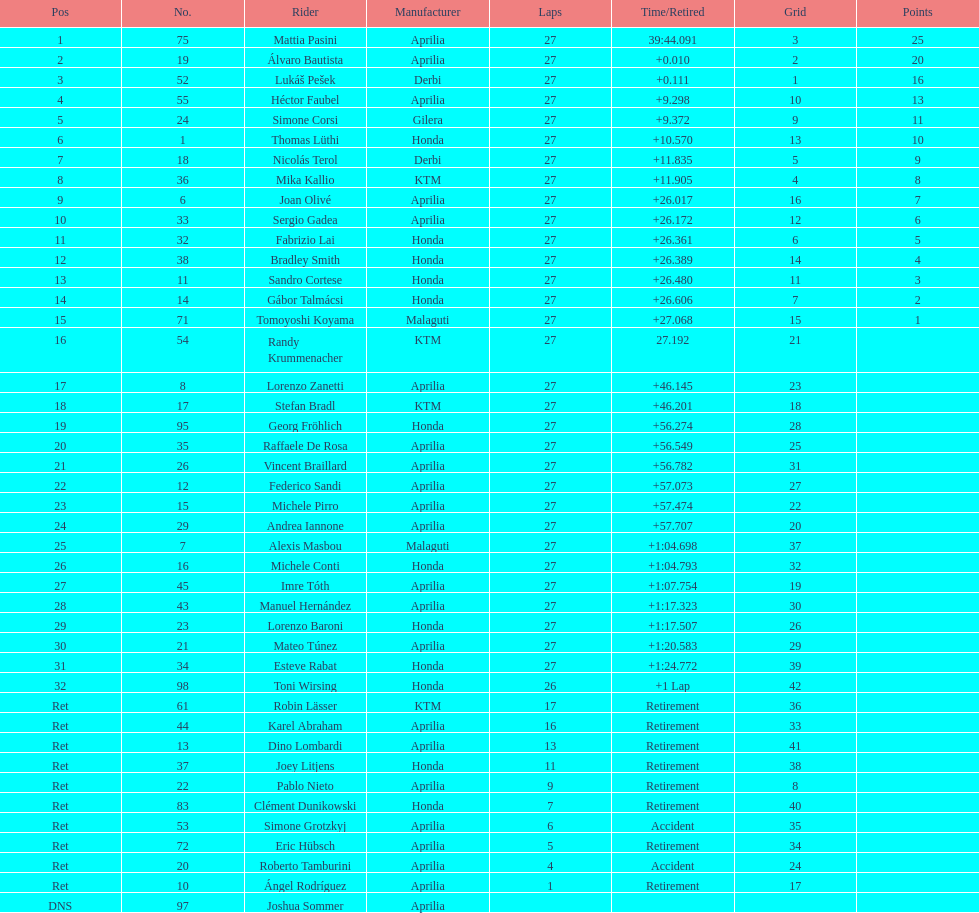What number of german racers finished the race? 4. 